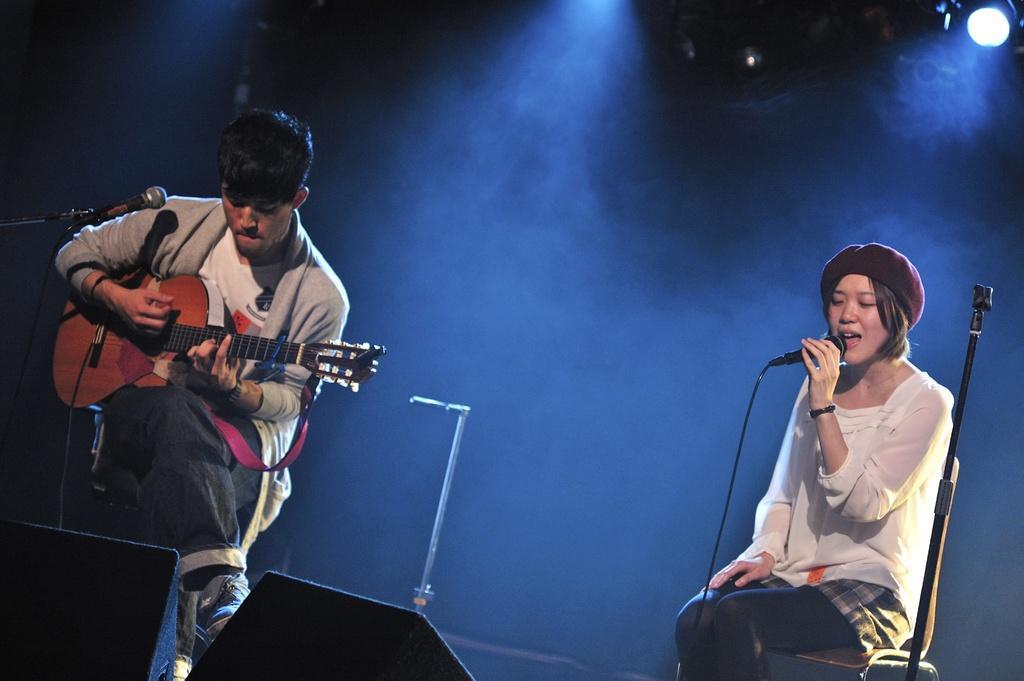Could you give a brief overview of what you see in this image? Bottom right side of the image a woman is sitting and holding microphone and singing. Bottom left side of the image a man is sitting and holding a guitar and playing. Top left side of the image there is a microphone. Top right side of the image there are some lights. 